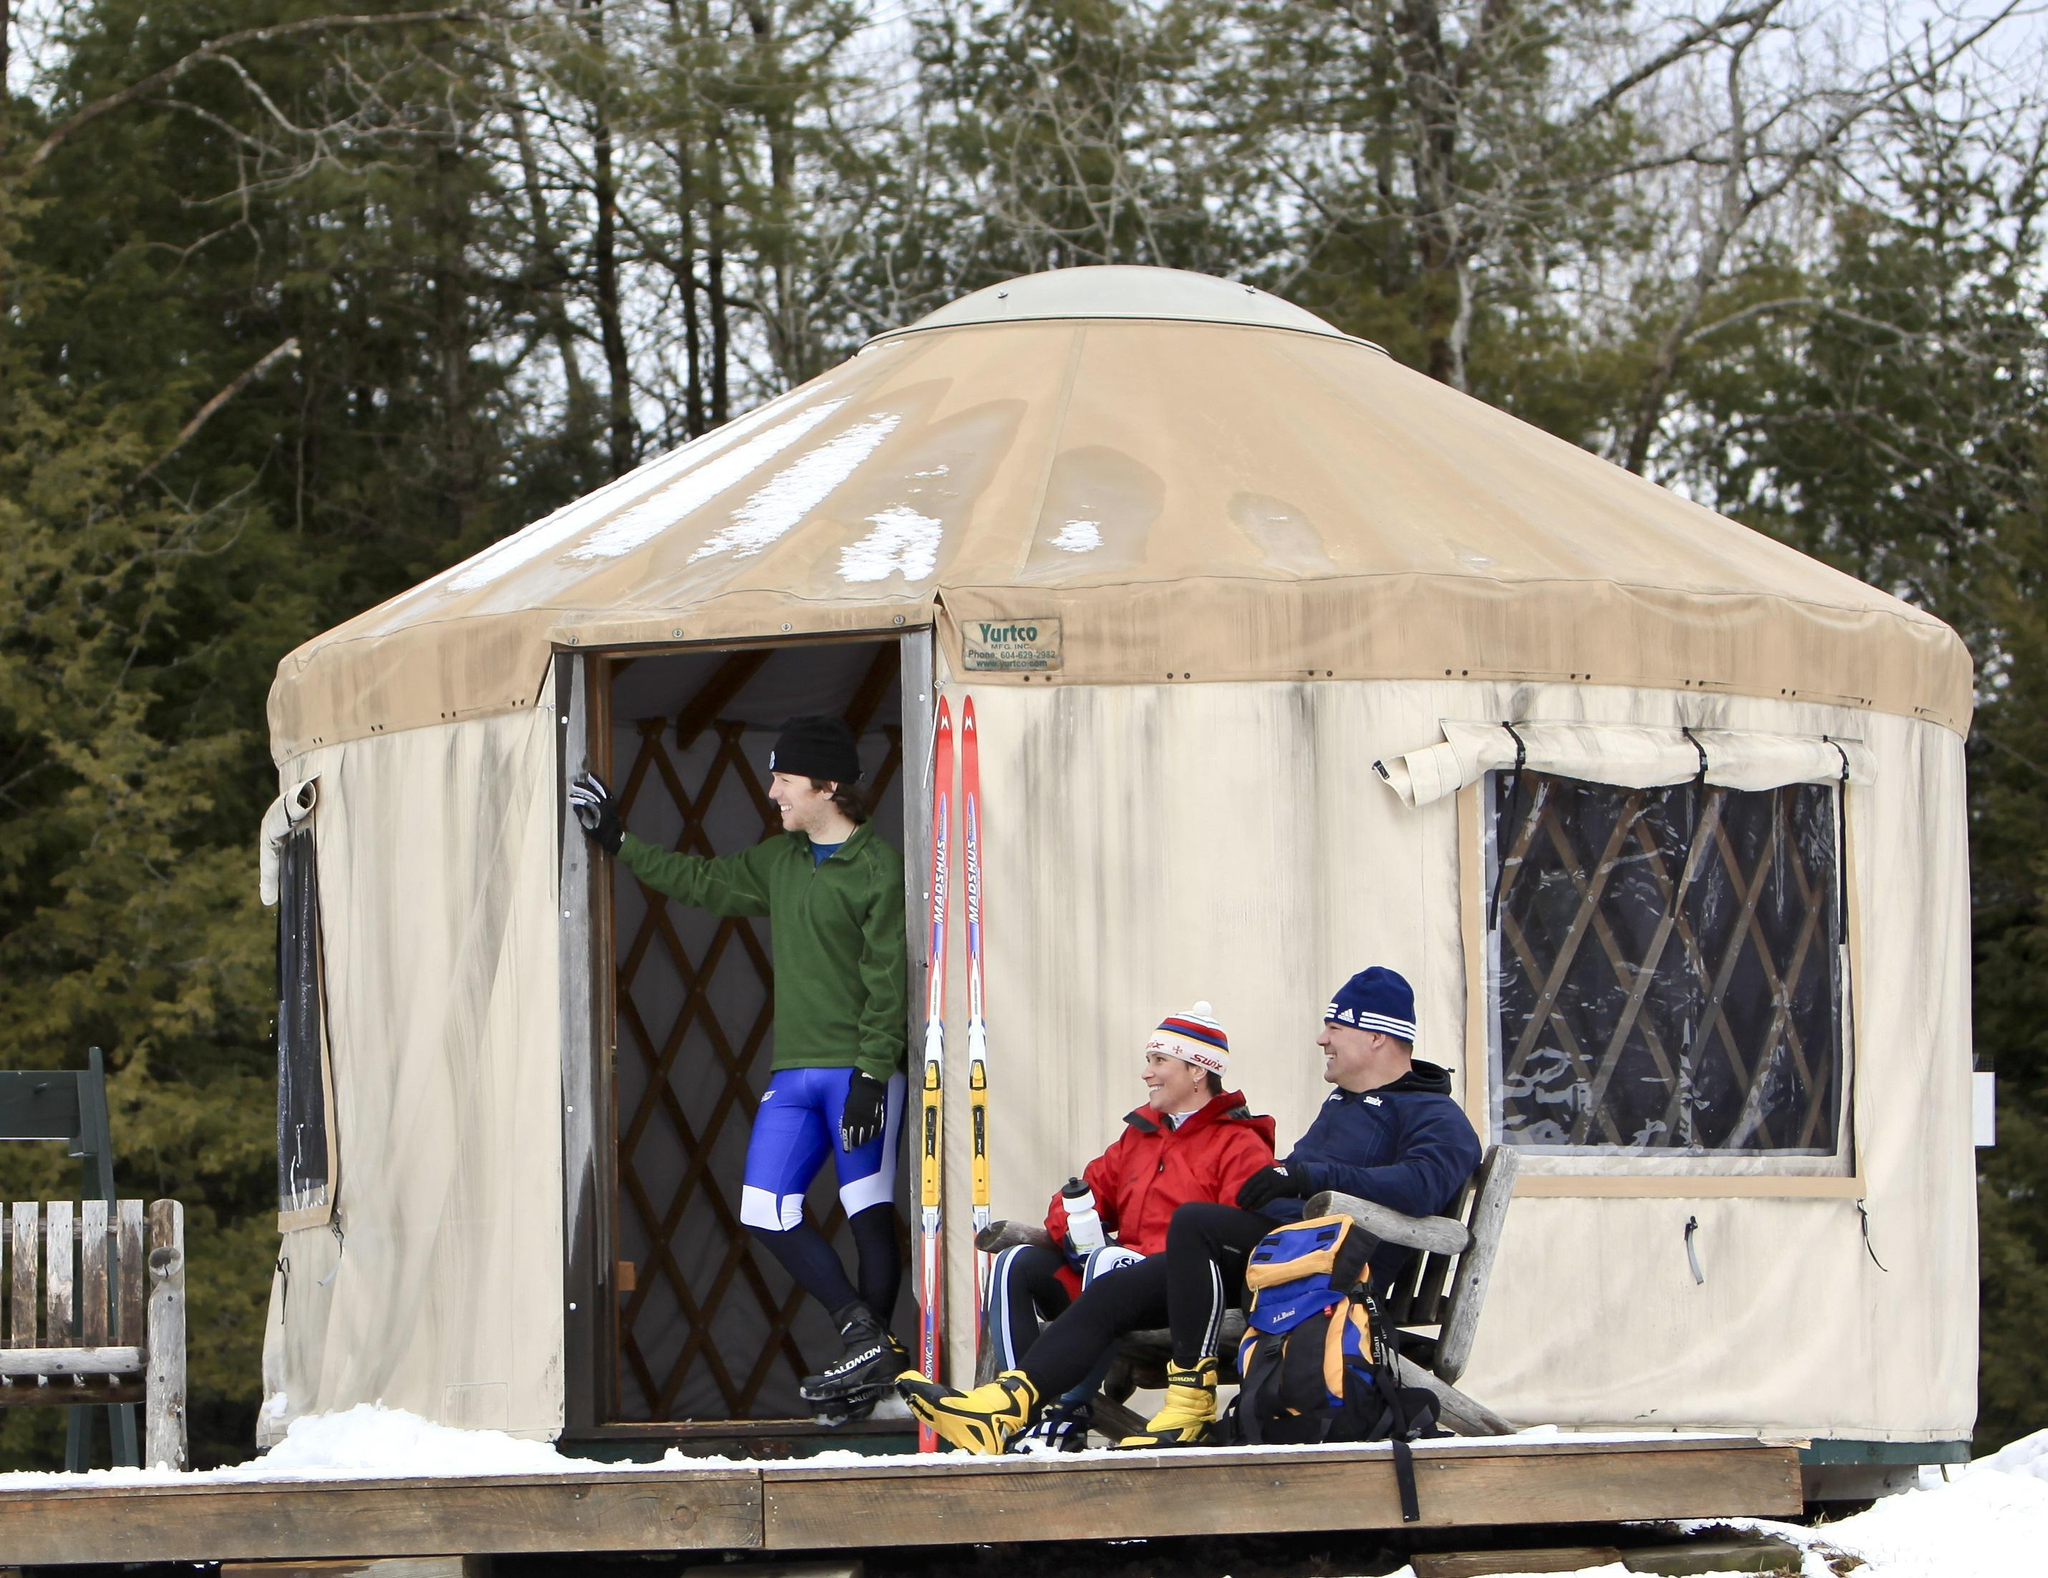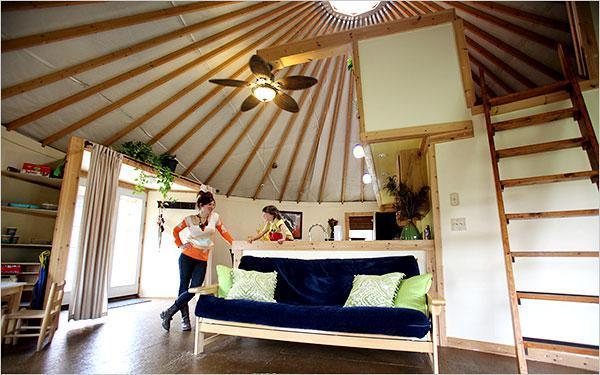The first image is the image on the left, the second image is the image on the right. Analyze the images presented: Is the assertion "Both images are inside a yurt and the table in one of them is on top of a rug." valid? Answer yes or no. No. The first image is the image on the left, the second image is the image on the right. Evaluate the accuracy of this statement regarding the images: "At least one table is at the foot of the bed.". Is it true? Answer yes or no. No. 